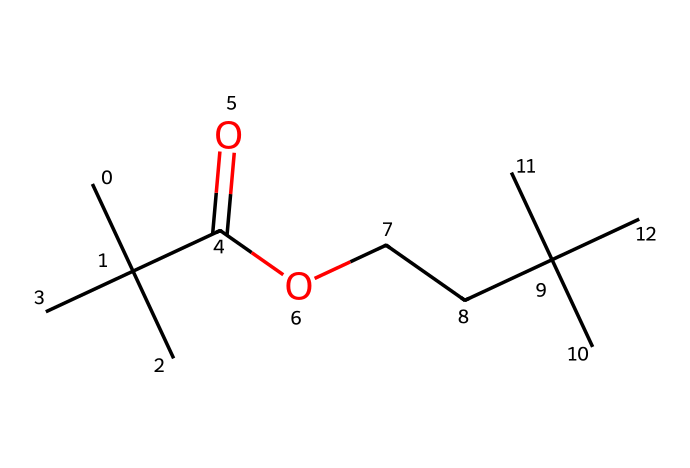What is the total number of carbon atoms in this chemical? By examining the SMILES representation, I can count the carbon (C) atoms present. There are 10 carbon atoms in total as indicated by the 'C' characters in the structure.
Answer: 10 How many oxygen atoms are present in the molecule? In the provided SMILES, the 'O' appears twice, indicating there are 2 oxygen atoms within the chemical structure.
Answer: 2 What type of functional group is present in this chemical? The presence of the 'C(=O)O' part of the SMILES indicates a carboxylic acid functional group due to the carbonyl (C=O) and hydroxyl (O) components.
Answer: carboxylic acid Is this polymer likely to be hydrophobic or hydrophilic? Considering the presence of the carboxylic acid functional group, which can interact with water, along with the large carbon backbone, it suggests that this polymer has some hydrophilic properties, although the aliphatic segments remain primarily hydrophobic.
Answer: hydrophilic Does this chemical have branching in its structure? The presence of multiple carbon atoms like 'C(C)(C)' indicates that there are branching points within the molecule, which classify it as a branched polymer.
Answer: branched What type of polymer might this chemical represent based on its structure? The presence of a branched structure and the functional group suggests this could represent a type of polyester or polyol, typically used in coatings which are suitable for document preservation.
Answer: polyester 